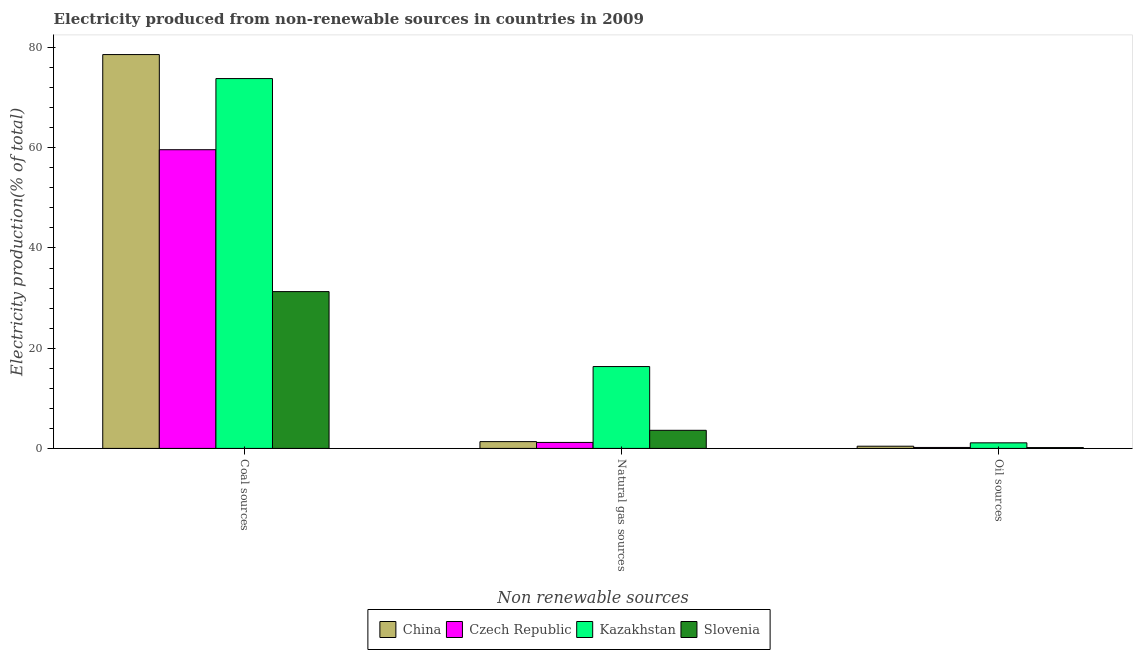How many different coloured bars are there?
Offer a very short reply. 4. How many bars are there on the 1st tick from the left?
Offer a very short reply. 4. What is the label of the 1st group of bars from the left?
Keep it short and to the point. Coal sources. What is the percentage of electricity produced by natural gas in China?
Your answer should be compact. 1.36. Across all countries, what is the maximum percentage of electricity produced by coal?
Your response must be concise. 78.59. Across all countries, what is the minimum percentage of electricity produced by oil sources?
Give a very brief answer. 0.17. In which country was the percentage of electricity produced by coal minimum?
Your answer should be compact. Slovenia. What is the total percentage of electricity produced by natural gas in the graph?
Ensure brevity in your answer.  22.5. What is the difference between the percentage of electricity produced by coal in Kazakhstan and that in Czech Republic?
Provide a succinct answer. 14.2. What is the difference between the percentage of electricity produced by natural gas in China and the percentage of electricity produced by oil sources in Kazakhstan?
Make the answer very short. 0.24. What is the average percentage of electricity produced by natural gas per country?
Give a very brief answer. 5.63. What is the difference between the percentage of electricity produced by coal and percentage of electricity produced by natural gas in Kazakhstan?
Make the answer very short. 57.47. What is the ratio of the percentage of electricity produced by natural gas in Slovenia to that in Czech Republic?
Give a very brief answer. 3.03. Is the difference between the percentage of electricity produced by natural gas in Kazakhstan and Slovenia greater than the difference between the percentage of electricity produced by coal in Kazakhstan and Slovenia?
Offer a very short reply. No. What is the difference between the highest and the second highest percentage of electricity produced by natural gas?
Keep it short and to the point. 12.72. What is the difference between the highest and the lowest percentage of electricity produced by coal?
Give a very brief answer. 47.3. What does the 3rd bar from the left in Coal sources represents?
Your response must be concise. Kazakhstan. What does the 1st bar from the right in Natural gas sources represents?
Keep it short and to the point. Slovenia. How many bars are there?
Offer a terse response. 12. How many countries are there in the graph?
Your answer should be very brief. 4. What is the difference between two consecutive major ticks on the Y-axis?
Your answer should be compact. 20. Are the values on the major ticks of Y-axis written in scientific E-notation?
Provide a short and direct response. No. How are the legend labels stacked?
Offer a terse response. Horizontal. What is the title of the graph?
Offer a very short reply. Electricity produced from non-renewable sources in countries in 2009. Does "Mongolia" appear as one of the legend labels in the graph?
Offer a very short reply. No. What is the label or title of the X-axis?
Give a very brief answer. Non renewable sources. What is the label or title of the Y-axis?
Ensure brevity in your answer.  Electricity production(% of total). What is the Electricity production(% of total) in China in Coal sources?
Your answer should be very brief. 78.59. What is the Electricity production(% of total) in Czech Republic in Coal sources?
Ensure brevity in your answer.  59.6. What is the Electricity production(% of total) of Kazakhstan in Coal sources?
Provide a short and direct response. 73.8. What is the Electricity production(% of total) of Slovenia in Coal sources?
Your response must be concise. 31.29. What is the Electricity production(% of total) in China in Natural gas sources?
Provide a short and direct response. 1.36. What is the Electricity production(% of total) in Czech Republic in Natural gas sources?
Your answer should be very brief. 1.19. What is the Electricity production(% of total) in Kazakhstan in Natural gas sources?
Provide a short and direct response. 16.33. What is the Electricity production(% of total) of Slovenia in Natural gas sources?
Keep it short and to the point. 3.62. What is the Electricity production(% of total) in China in Oil sources?
Offer a terse response. 0.44. What is the Electricity production(% of total) in Czech Republic in Oil sources?
Provide a short and direct response. 0.19. What is the Electricity production(% of total) of Kazakhstan in Oil sources?
Offer a terse response. 1.11. What is the Electricity production(% of total) in Slovenia in Oil sources?
Ensure brevity in your answer.  0.17. Across all Non renewable sources, what is the maximum Electricity production(% of total) of China?
Make the answer very short. 78.59. Across all Non renewable sources, what is the maximum Electricity production(% of total) of Czech Republic?
Provide a succinct answer. 59.6. Across all Non renewable sources, what is the maximum Electricity production(% of total) in Kazakhstan?
Offer a very short reply. 73.8. Across all Non renewable sources, what is the maximum Electricity production(% of total) of Slovenia?
Your response must be concise. 31.29. Across all Non renewable sources, what is the minimum Electricity production(% of total) of China?
Offer a very short reply. 0.44. Across all Non renewable sources, what is the minimum Electricity production(% of total) of Czech Republic?
Give a very brief answer. 0.19. Across all Non renewable sources, what is the minimum Electricity production(% of total) of Kazakhstan?
Provide a succinct answer. 1.11. Across all Non renewable sources, what is the minimum Electricity production(% of total) of Slovenia?
Ensure brevity in your answer.  0.17. What is the total Electricity production(% of total) in China in the graph?
Your response must be concise. 80.39. What is the total Electricity production(% of total) in Czech Republic in the graph?
Your answer should be very brief. 60.99. What is the total Electricity production(% of total) of Kazakhstan in the graph?
Your response must be concise. 91.25. What is the total Electricity production(% of total) in Slovenia in the graph?
Your answer should be compact. 35.08. What is the difference between the Electricity production(% of total) of China in Coal sources and that in Natural gas sources?
Provide a short and direct response. 77.23. What is the difference between the Electricity production(% of total) of Czech Republic in Coal sources and that in Natural gas sources?
Keep it short and to the point. 58.41. What is the difference between the Electricity production(% of total) in Kazakhstan in Coal sources and that in Natural gas sources?
Keep it short and to the point. 57.47. What is the difference between the Electricity production(% of total) of Slovenia in Coal sources and that in Natural gas sources?
Offer a very short reply. 27.68. What is the difference between the Electricity production(% of total) of China in Coal sources and that in Oil sources?
Make the answer very short. 78.15. What is the difference between the Electricity production(% of total) of Czech Republic in Coal sources and that in Oil sources?
Offer a very short reply. 59.41. What is the difference between the Electricity production(% of total) in Kazakhstan in Coal sources and that in Oil sources?
Keep it short and to the point. 72.69. What is the difference between the Electricity production(% of total) of Slovenia in Coal sources and that in Oil sources?
Keep it short and to the point. 31.12. What is the difference between the Electricity production(% of total) of China in Natural gas sources and that in Oil sources?
Offer a terse response. 0.92. What is the difference between the Electricity production(% of total) in Kazakhstan in Natural gas sources and that in Oil sources?
Provide a succinct answer. 15.22. What is the difference between the Electricity production(% of total) of Slovenia in Natural gas sources and that in Oil sources?
Give a very brief answer. 3.44. What is the difference between the Electricity production(% of total) of China in Coal sources and the Electricity production(% of total) of Czech Republic in Natural gas sources?
Make the answer very short. 77.4. What is the difference between the Electricity production(% of total) of China in Coal sources and the Electricity production(% of total) of Kazakhstan in Natural gas sources?
Provide a short and direct response. 62.26. What is the difference between the Electricity production(% of total) in China in Coal sources and the Electricity production(% of total) in Slovenia in Natural gas sources?
Provide a short and direct response. 74.98. What is the difference between the Electricity production(% of total) of Czech Republic in Coal sources and the Electricity production(% of total) of Kazakhstan in Natural gas sources?
Your response must be concise. 43.27. What is the difference between the Electricity production(% of total) in Czech Republic in Coal sources and the Electricity production(% of total) in Slovenia in Natural gas sources?
Keep it short and to the point. 55.99. What is the difference between the Electricity production(% of total) of Kazakhstan in Coal sources and the Electricity production(% of total) of Slovenia in Natural gas sources?
Ensure brevity in your answer.  70.19. What is the difference between the Electricity production(% of total) of China in Coal sources and the Electricity production(% of total) of Czech Republic in Oil sources?
Make the answer very short. 78.4. What is the difference between the Electricity production(% of total) in China in Coal sources and the Electricity production(% of total) in Kazakhstan in Oil sources?
Give a very brief answer. 77.48. What is the difference between the Electricity production(% of total) in China in Coal sources and the Electricity production(% of total) in Slovenia in Oil sources?
Provide a short and direct response. 78.42. What is the difference between the Electricity production(% of total) in Czech Republic in Coal sources and the Electricity production(% of total) in Kazakhstan in Oil sources?
Your answer should be very brief. 58.49. What is the difference between the Electricity production(% of total) of Czech Republic in Coal sources and the Electricity production(% of total) of Slovenia in Oil sources?
Provide a short and direct response. 59.43. What is the difference between the Electricity production(% of total) in Kazakhstan in Coal sources and the Electricity production(% of total) in Slovenia in Oil sources?
Offer a terse response. 73.63. What is the difference between the Electricity production(% of total) in China in Natural gas sources and the Electricity production(% of total) in Czech Republic in Oil sources?
Provide a succinct answer. 1.17. What is the difference between the Electricity production(% of total) in China in Natural gas sources and the Electricity production(% of total) in Kazakhstan in Oil sources?
Make the answer very short. 0.24. What is the difference between the Electricity production(% of total) of China in Natural gas sources and the Electricity production(% of total) of Slovenia in Oil sources?
Offer a terse response. 1.19. What is the difference between the Electricity production(% of total) of Czech Republic in Natural gas sources and the Electricity production(% of total) of Kazakhstan in Oil sources?
Provide a succinct answer. 0.08. What is the difference between the Electricity production(% of total) in Czech Republic in Natural gas sources and the Electricity production(% of total) in Slovenia in Oil sources?
Offer a very short reply. 1.02. What is the difference between the Electricity production(% of total) of Kazakhstan in Natural gas sources and the Electricity production(% of total) of Slovenia in Oil sources?
Offer a very short reply. 16.16. What is the average Electricity production(% of total) in China per Non renewable sources?
Your response must be concise. 26.8. What is the average Electricity production(% of total) in Czech Republic per Non renewable sources?
Ensure brevity in your answer.  20.33. What is the average Electricity production(% of total) in Kazakhstan per Non renewable sources?
Offer a terse response. 30.42. What is the average Electricity production(% of total) of Slovenia per Non renewable sources?
Provide a short and direct response. 11.69. What is the difference between the Electricity production(% of total) in China and Electricity production(% of total) in Czech Republic in Coal sources?
Offer a very short reply. 18.99. What is the difference between the Electricity production(% of total) of China and Electricity production(% of total) of Kazakhstan in Coal sources?
Provide a short and direct response. 4.79. What is the difference between the Electricity production(% of total) in China and Electricity production(% of total) in Slovenia in Coal sources?
Offer a terse response. 47.3. What is the difference between the Electricity production(% of total) in Czech Republic and Electricity production(% of total) in Kazakhstan in Coal sources?
Your answer should be very brief. -14.2. What is the difference between the Electricity production(% of total) in Czech Republic and Electricity production(% of total) in Slovenia in Coal sources?
Your response must be concise. 28.31. What is the difference between the Electricity production(% of total) of Kazakhstan and Electricity production(% of total) of Slovenia in Coal sources?
Your response must be concise. 42.51. What is the difference between the Electricity production(% of total) in China and Electricity production(% of total) in Czech Republic in Natural gas sources?
Offer a very short reply. 0.16. What is the difference between the Electricity production(% of total) of China and Electricity production(% of total) of Kazakhstan in Natural gas sources?
Ensure brevity in your answer.  -14.98. What is the difference between the Electricity production(% of total) of China and Electricity production(% of total) of Slovenia in Natural gas sources?
Offer a very short reply. -2.26. What is the difference between the Electricity production(% of total) of Czech Republic and Electricity production(% of total) of Kazakhstan in Natural gas sources?
Your answer should be very brief. -15.14. What is the difference between the Electricity production(% of total) in Czech Republic and Electricity production(% of total) in Slovenia in Natural gas sources?
Keep it short and to the point. -2.42. What is the difference between the Electricity production(% of total) in Kazakhstan and Electricity production(% of total) in Slovenia in Natural gas sources?
Provide a succinct answer. 12.72. What is the difference between the Electricity production(% of total) of China and Electricity production(% of total) of Czech Republic in Oil sources?
Ensure brevity in your answer.  0.25. What is the difference between the Electricity production(% of total) in China and Electricity production(% of total) in Kazakhstan in Oil sources?
Offer a terse response. -0.67. What is the difference between the Electricity production(% of total) of China and Electricity production(% of total) of Slovenia in Oil sources?
Offer a very short reply. 0.27. What is the difference between the Electricity production(% of total) in Czech Republic and Electricity production(% of total) in Kazakhstan in Oil sources?
Offer a very short reply. -0.92. What is the difference between the Electricity production(% of total) of Czech Republic and Electricity production(% of total) of Slovenia in Oil sources?
Ensure brevity in your answer.  0.02. What is the difference between the Electricity production(% of total) of Kazakhstan and Electricity production(% of total) of Slovenia in Oil sources?
Provide a short and direct response. 0.94. What is the ratio of the Electricity production(% of total) of China in Coal sources to that in Natural gas sources?
Provide a short and direct response. 57.88. What is the ratio of the Electricity production(% of total) in Czech Republic in Coal sources to that in Natural gas sources?
Make the answer very short. 49.94. What is the ratio of the Electricity production(% of total) of Kazakhstan in Coal sources to that in Natural gas sources?
Ensure brevity in your answer.  4.52. What is the ratio of the Electricity production(% of total) of Slovenia in Coal sources to that in Natural gas sources?
Make the answer very short. 8.65. What is the ratio of the Electricity production(% of total) of China in Coal sources to that in Oil sources?
Provide a succinct answer. 178.3. What is the ratio of the Electricity production(% of total) of Czech Republic in Coal sources to that in Oil sources?
Provide a short and direct response. 312.15. What is the ratio of the Electricity production(% of total) of Kazakhstan in Coal sources to that in Oil sources?
Provide a succinct answer. 66.24. What is the ratio of the Electricity production(% of total) of Slovenia in Coal sources to that in Oil sources?
Offer a terse response. 183.29. What is the ratio of the Electricity production(% of total) in China in Natural gas sources to that in Oil sources?
Your response must be concise. 3.08. What is the ratio of the Electricity production(% of total) of Czech Republic in Natural gas sources to that in Oil sources?
Ensure brevity in your answer.  6.25. What is the ratio of the Electricity production(% of total) of Kazakhstan in Natural gas sources to that in Oil sources?
Provide a short and direct response. 14.66. What is the ratio of the Electricity production(% of total) in Slovenia in Natural gas sources to that in Oil sources?
Your response must be concise. 21.18. What is the difference between the highest and the second highest Electricity production(% of total) in China?
Your answer should be very brief. 77.23. What is the difference between the highest and the second highest Electricity production(% of total) in Czech Republic?
Make the answer very short. 58.41. What is the difference between the highest and the second highest Electricity production(% of total) in Kazakhstan?
Ensure brevity in your answer.  57.47. What is the difference between the highest and the second highest Electricity production(% of total) in Slovenia?
Your response must be concise. 27.68. What is the difference between the highest and the lowest Electricity production(% of total) in China?
Make the answer very short. 78.15. What is the difference between the highest and the lowest Electricity production(% of total) of Czech Republic?
Give a very brief answer. 59.41. What is the difference between the highest and the lowest Electricity production(% of total) in Kazakhstan?
Your answer should be very brief. 72.69. What is the difference between the highest and the lowest Electricity production(% of total) in Slovenia?
Provide a short and direct response. 31.12. 